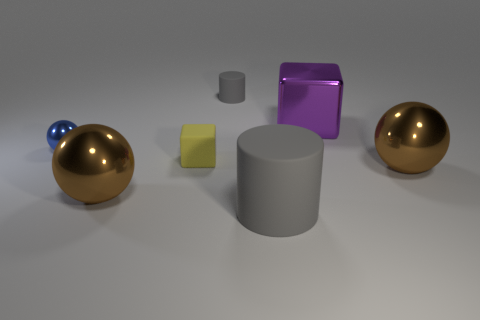Add 2 small blue rubber cubes. How many objects exist? 9 Subtract all blue metal spheres. How many spheres are left? 2 Subtract all yellow cubes. How many cubes are left? 1 Subtract all red cylinders. How many brown spheres are left? 2 Subtract 0 brown cubes. How many objects are left? 7 Subtract all cubes. How many objects are left? 5 Subtract 1 spheres. How many spheres are left? 2 Subtract all green cylinders. Subtract all red cubes. How many cylinders are left? 2 Subtract all big purple metallic cubes. Subtract all tiny rubber cubes. How many objects are left? 5 Add 3 yellow blocks. How many yellow blocks are left? 4 